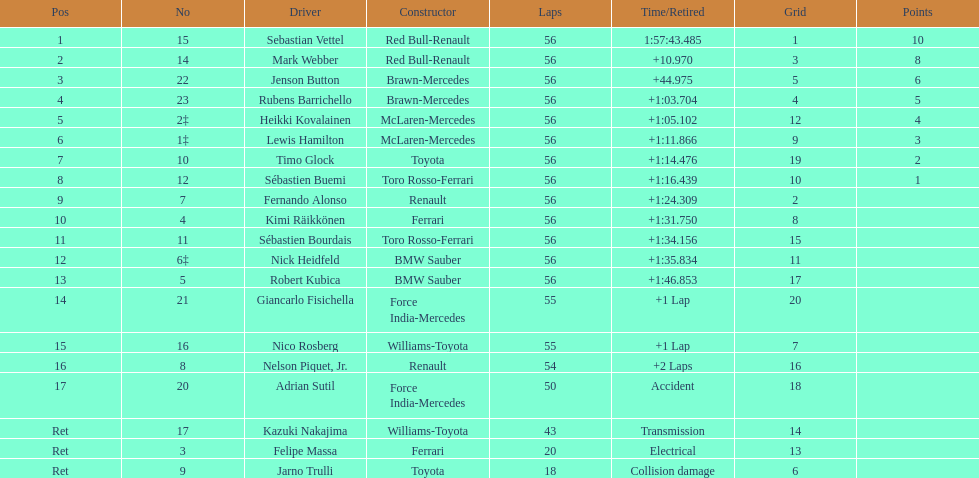Heikki kovalainen and lewis hamilton both had which constructor? McLaren-Mercedes. 